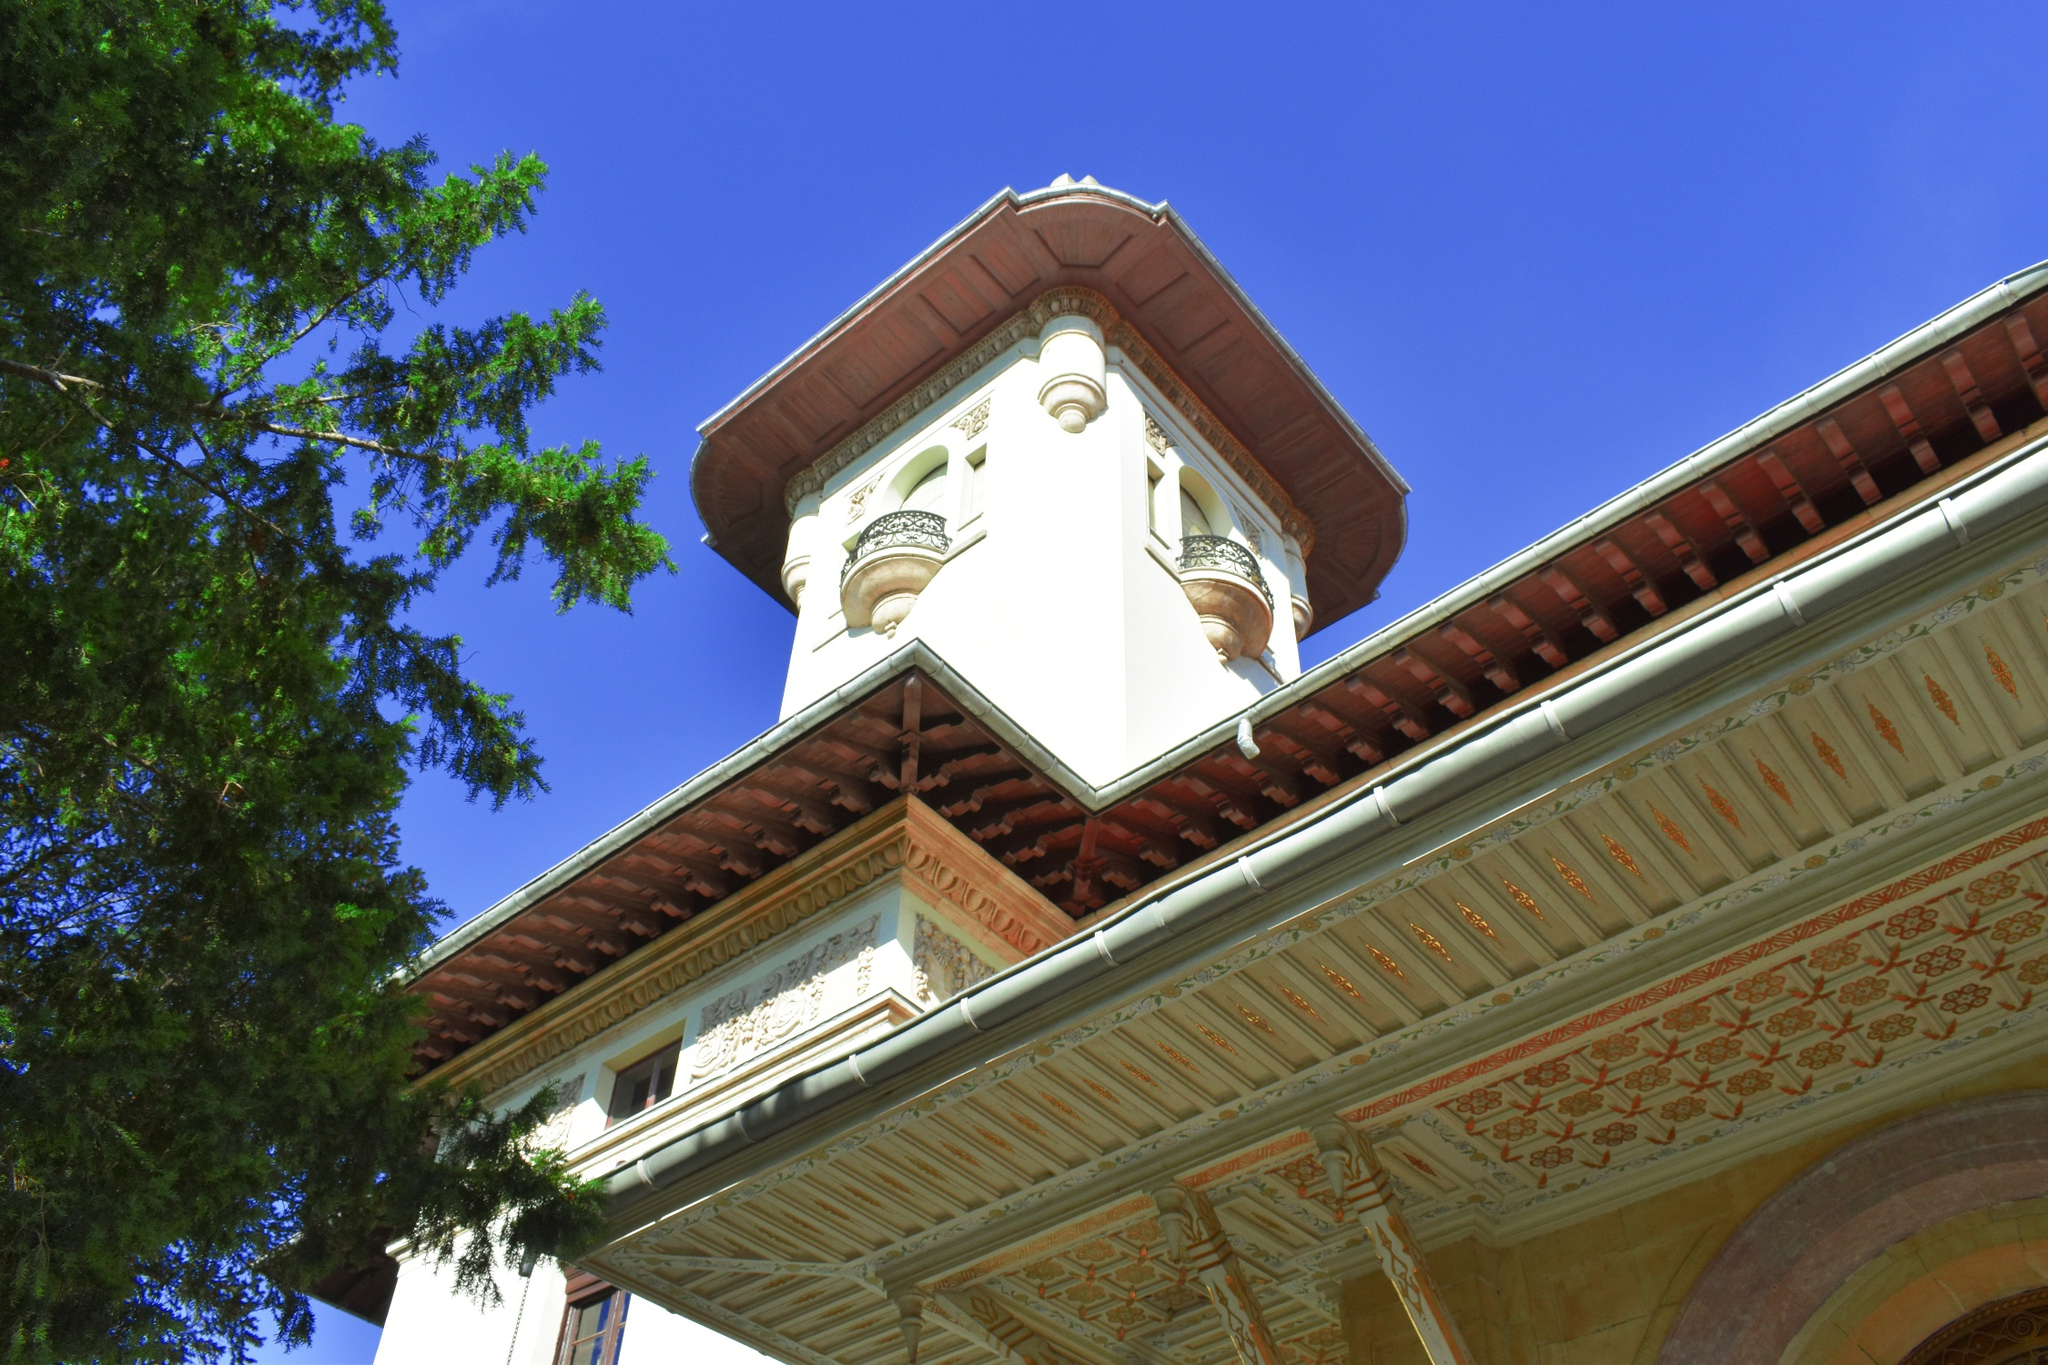How might this building be used in a modern setting? In a modern setting, this striking building could serve various purposes, blending its historical charm with contemporary functionality. It could be repurposed as a cultural heritage museum, showcasing the rich history of its architecture and the region. Alternatively, it could function as a luxury boutique hotel, offering guests a stay in an environment that combines historical elegance with modern amenities. The tower could house a panoramic restaurant or a rooftop café, providing visitors with stunning views and a unique dining experience. It might also serve as an event venue for weddings, art exhibitions, and conferences, leveraging its grandeur to create memorable experiences for visitors and participants.  What emotions might someone feel when visiting this place? Visitors to this place might experience a mix of awe and tranquility. The building's grandeur and intricate details could evoke feelings of admiration and wonder, while the serene surroundings of lush greenery would provide a sense of peace and relaxation. The historical charm of the architecture might also inspire a deep appreciation for the craftsmanship and design ingenuity of the past, as well as a sense of connection to history and culture. Overall, the emotions felt would be a harmonious blend of awe, peace, and a profound respect for the beauty and significance of the structure. 